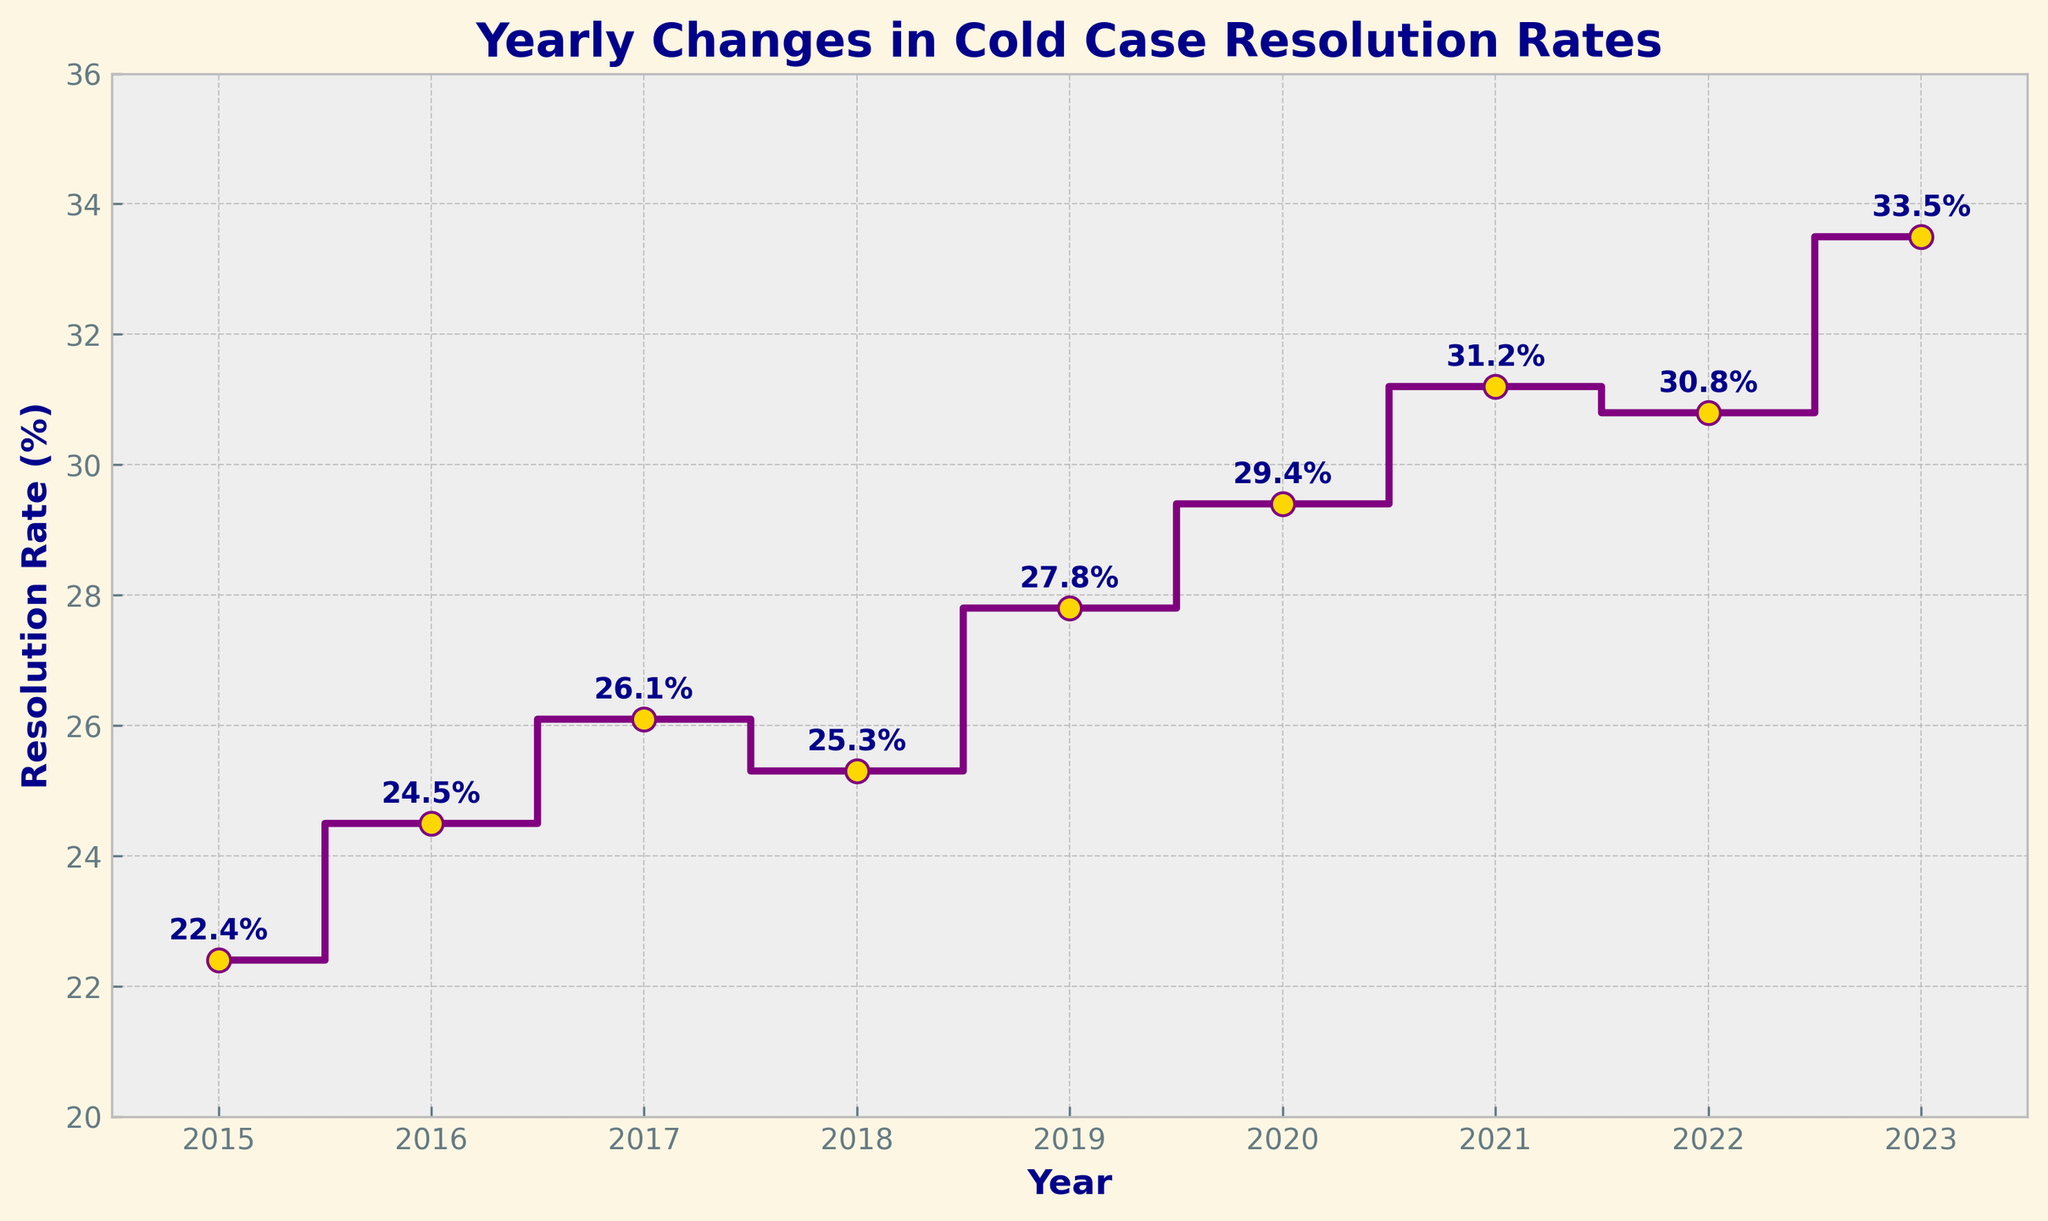What is the title of the plot? The title is written at the top of the plot.
Answer: Yearly Changes in Cold Case Resolution Rates What is the resolution rate in 2020? The resolution rate can be found by following the 2020 marker on the x-axis to the corresponding y-axis value.
Answer: 29.4% What year had the highest resolution rate? Look for the highest point on the plot and find the corresponding year on the x-axis.
Answer: 2023 What is the difference in resolution rates between 2017 and 2018? Find the y-axis values for 2017 and 2018, then subtract the rate of 2018 from the rate of 2017: 26.1 - 25.3 = 0.8.
Answer: 0.8% How many years saw an increase in the resolution rate compared to the previous year? Count the upward steps in the plot where the rate increased from one year to the next: 2016, 2017, 2019, 2020, 2021, 2023.
Answer: 6 years What is the average resolution rate from 2015 to 2023? Sum the resolution rates from 2015 to 2023 and divide by the number of years: (22.4 + 24.5 + 26.1 + 25.3 + 27.8 + 29.4 + 31.2 + 30.8 + 33.5) / 9 = 27.78.
Answer: 27.78% By how much did the resolution rate change from 2019 to 2023? Subtract the 2019 rate from the 2023 rate: 33.5 - 27.8 = 5.7.
Answer: 5.7% In which years did the resolution rate decrease compared to the previous year? Identify the downward steps in the plot: 2018 and 2022 had lower rates than their previous years.
Answer: 2018, 2022 What is the trend of the resolution rates from 2015 to 2023? Analyze the general direction of the steps in the plot to identify if they are mostly increasing or decreasing.
Answer: Mostly increasing Which year saw the smallest change in the resolution rate compared to the previous year? Look for the smallest step (the smallest vertical distance between two points): The smallest increase is between 2017 (26.1) and 2018 (25.3), which is a decrease of 0.8.
Answer: 2018 